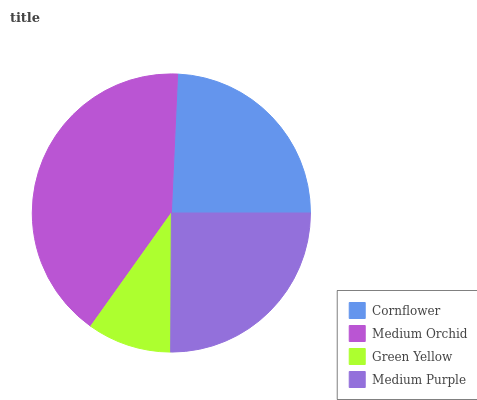Is Green Yellow the minimum?
Answer yes or no. Yes. Is Medium Orchid the maximum?
Answer yes or no. Yes. Is Medium Orchid the minimum?
Answer yes or no. No. Is Green Yellow the maximum?
Answer yes or no. No. Is Medium Orchid greater than Green Yellow?
Answer yes or no. Yes. Is Green Yellow less than Medium Orchid?
Answer yes or no. Yes. Is Green Yellow greater than Medium Orchid?
Answer yes or no. No. Is Medium Orchid less than Green Yellow?
Answer yes or no. No. Is Medium Purple the high median?
Answer yes or no. Yes. Is Cornflower the low median?
Answer yes or no. Yes. Is Medium Orchid the high median?
Answer yes or no. No. Is Medium Orchid the low median?
Answer yes or no. No. 